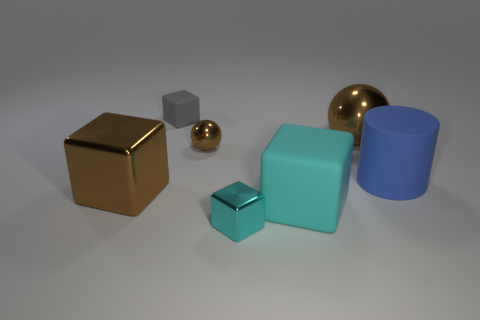What number of objects are either large shiny cubes or big cubes to the left of the tiny brown metal sphere?
Your answer should be very brief. 1. What is the size of the cyan cube that is made of the same material as the gray thing?
Provide a short and direct response. Large. Are there more large things in front of the matte cylinder than big brown metallic spheres?
Offer a terse response. Yes. There is a cube that is to the right of the big brown cube and behind the cyan matte thing; what size is it?
Give a very brief answer. Small. What material is the gray thing that is the same shape as the large cyan thing?
Your answer should be very brief. Rubber. Do the metal cube on the left side of the gray matte block and the large matte block have the same size?
Offer a terse response. Yes. What is the color of the small thing that is both right of the small gray block and behind the brown metal cube?
Your answer should be compact. Brown. How many brown spheres are on the left side of the big brown metallic sphere behind the blue object?
Your response must be concise. 1. Is the shape of the tiny gray matte object the same as the tiny brown thing?
Give a very brief answer. No. Is there any other thing that is the same color as the large matte block?
Offer a terse response. Yes. 